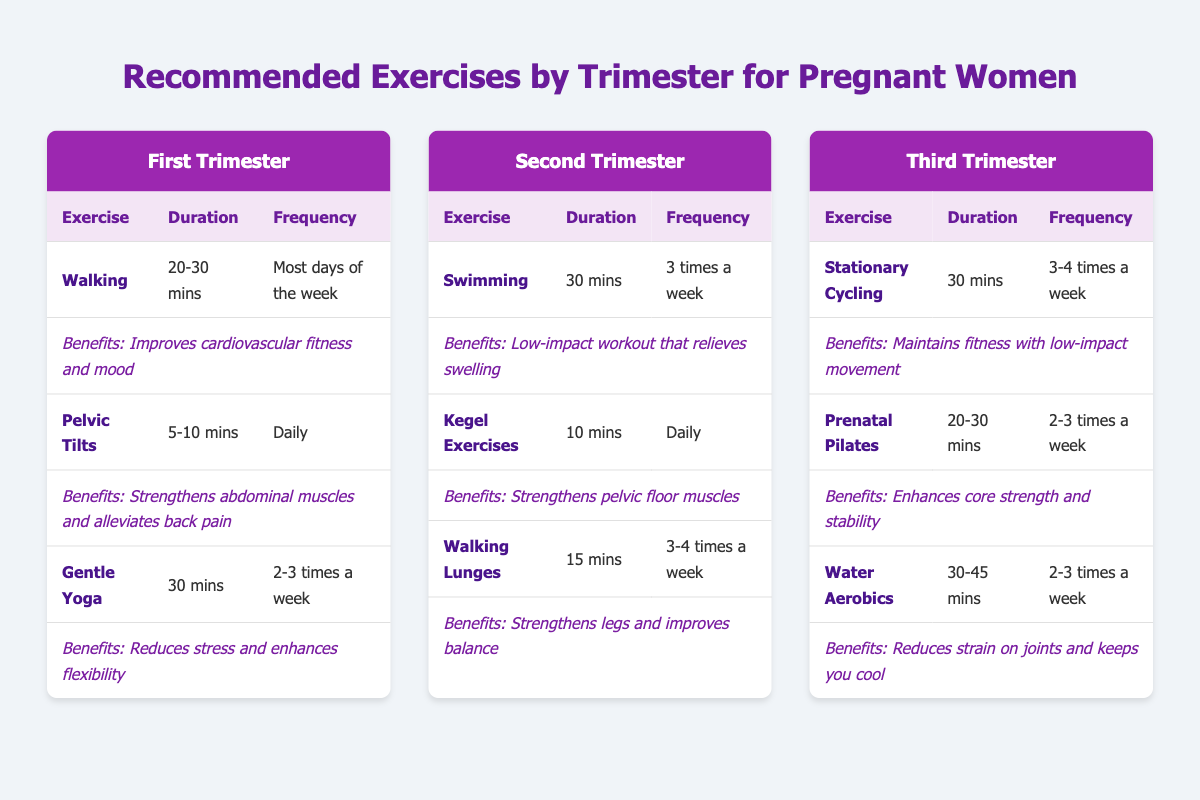What exercises are recommended for the first trimester? The table shows three exercises listed under the First Trimester: Walking, Pelvic Tilts, and Gentle Yoga.
Answer: Walking, Pelvic Tilts, Gentle Yoga How many times a week should I perform Kegel Exercises during the second trimester? The table states that Kegel Exercises should be done daily according to the second trimester section.
Answer: Daily Which exercise in the third trimester has the longest duration? In the third trimester, Water Aerobics has a duration of 30-45 mins, which is longer than the other exercises (Stationary Cycling and Prenatal Pilates).
Answer: Water Aerobics Is there any exercise that is recommended for all three trimesters? The table lists different exercises for each trimester, and none of the exercises appear in more than one trimester, so the answer is no.
Answer: No What is the average duration of the exercises recommended in the second trimester? The durations for the exercises in the second trimester are 30 mins (Swimming), 10 mins (Kegel Exercises), and 15 mins (Walking Lunges). The total duration is 30 + 10 + 15 = 55, and there are three exercises, so the average duration = 55 / 3 = approximately 18.33 mins.
Answer: 18.33 mins What benefit does Gentle Yoga provide according to the table? For Gentle Yoga, the table states that it reduces stress and enhances flexibility as its benefits.
Answer: Reduces stress and enhances flexibility How many exercises in the third trimester recommend a frequency of 2-3 times a week? In the third trimester, both Prenatal Pilates and Water Aerobics recommend a frequency of 2-3 times a week.
Answer: 2 Are Walking and Swimming both recommended exercises? Yes, Walking is listed for the first trimester, and Swimming is listed for the second trimester, so they are both recommended exercises.
Answer: Yes Which exercise during the first trimester has the specific benefit of alleviating back pain? Pelvic Tilts, as noted in the table, specifically mention the benefit of alleviating back pain.
Answer: Pelvic Tilts 